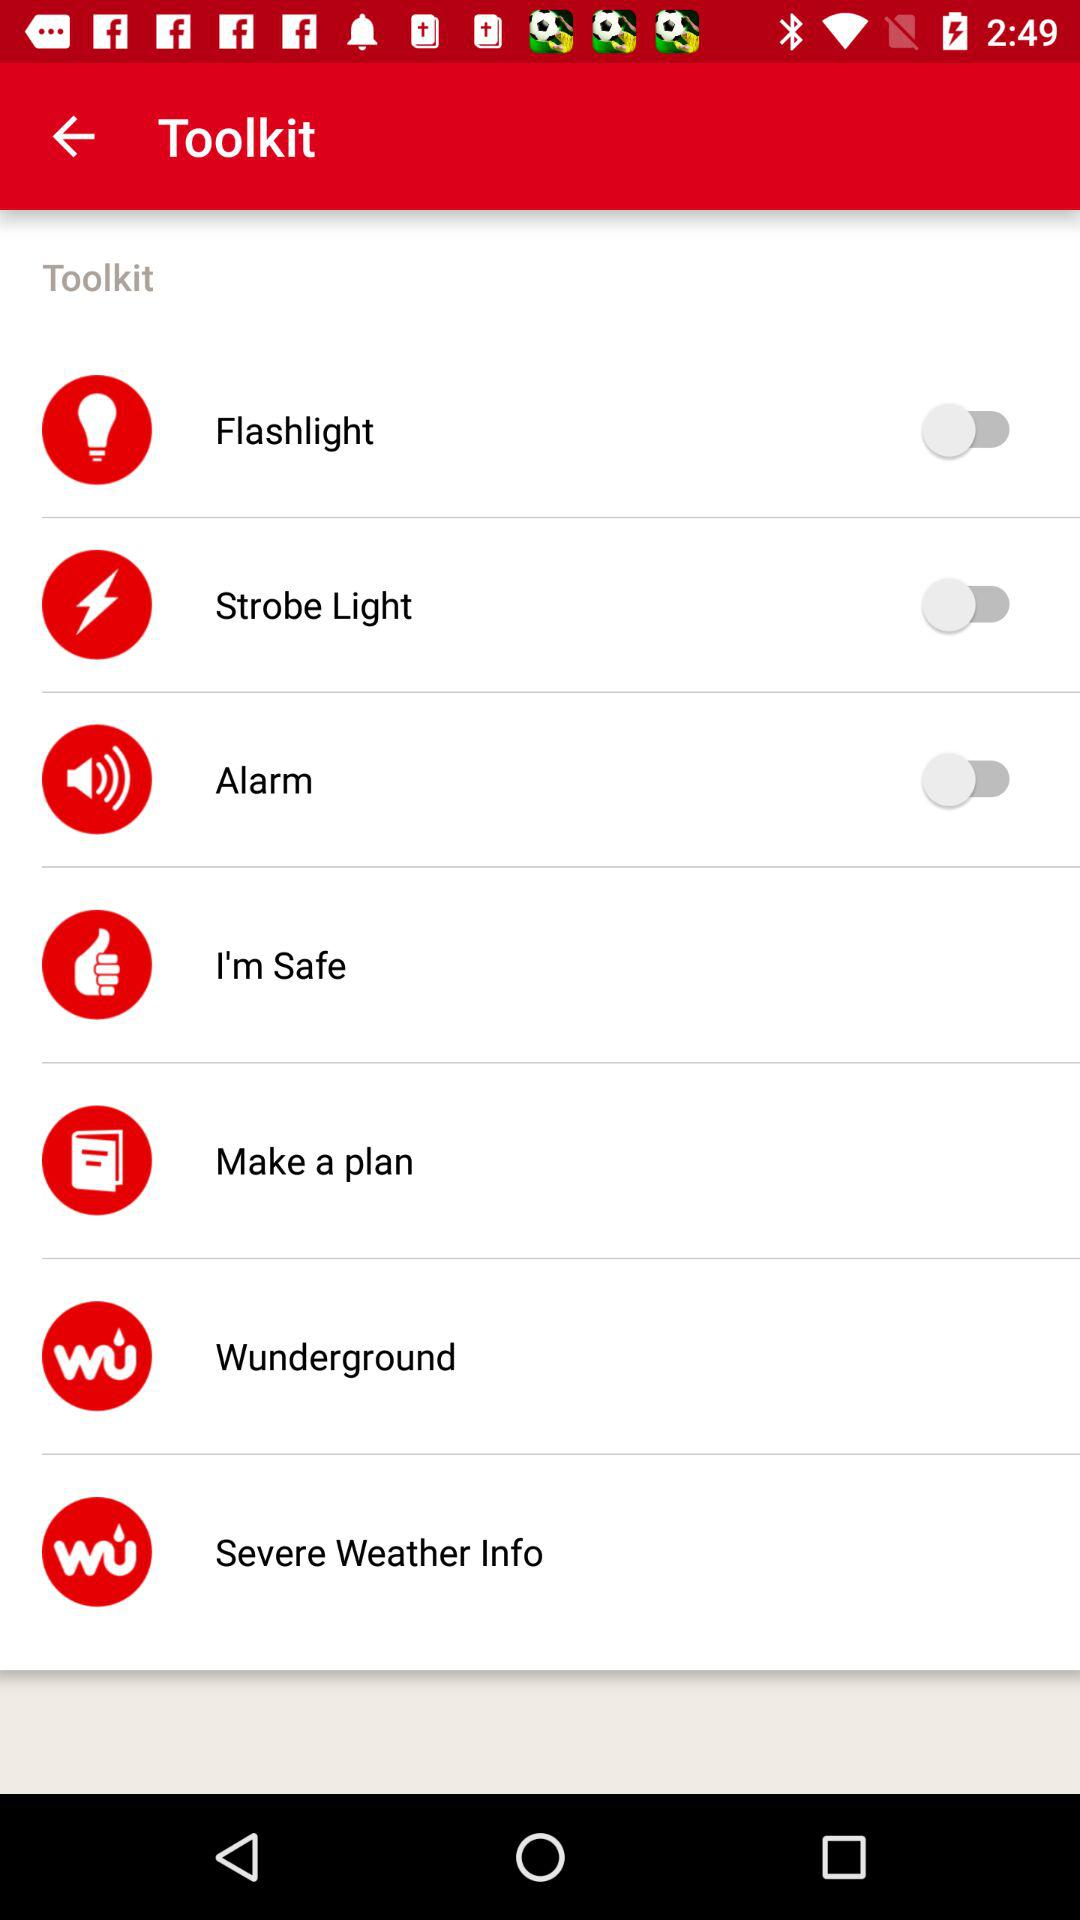What is the status of "Flashlight"? The status of "Flashlight" is "off". 